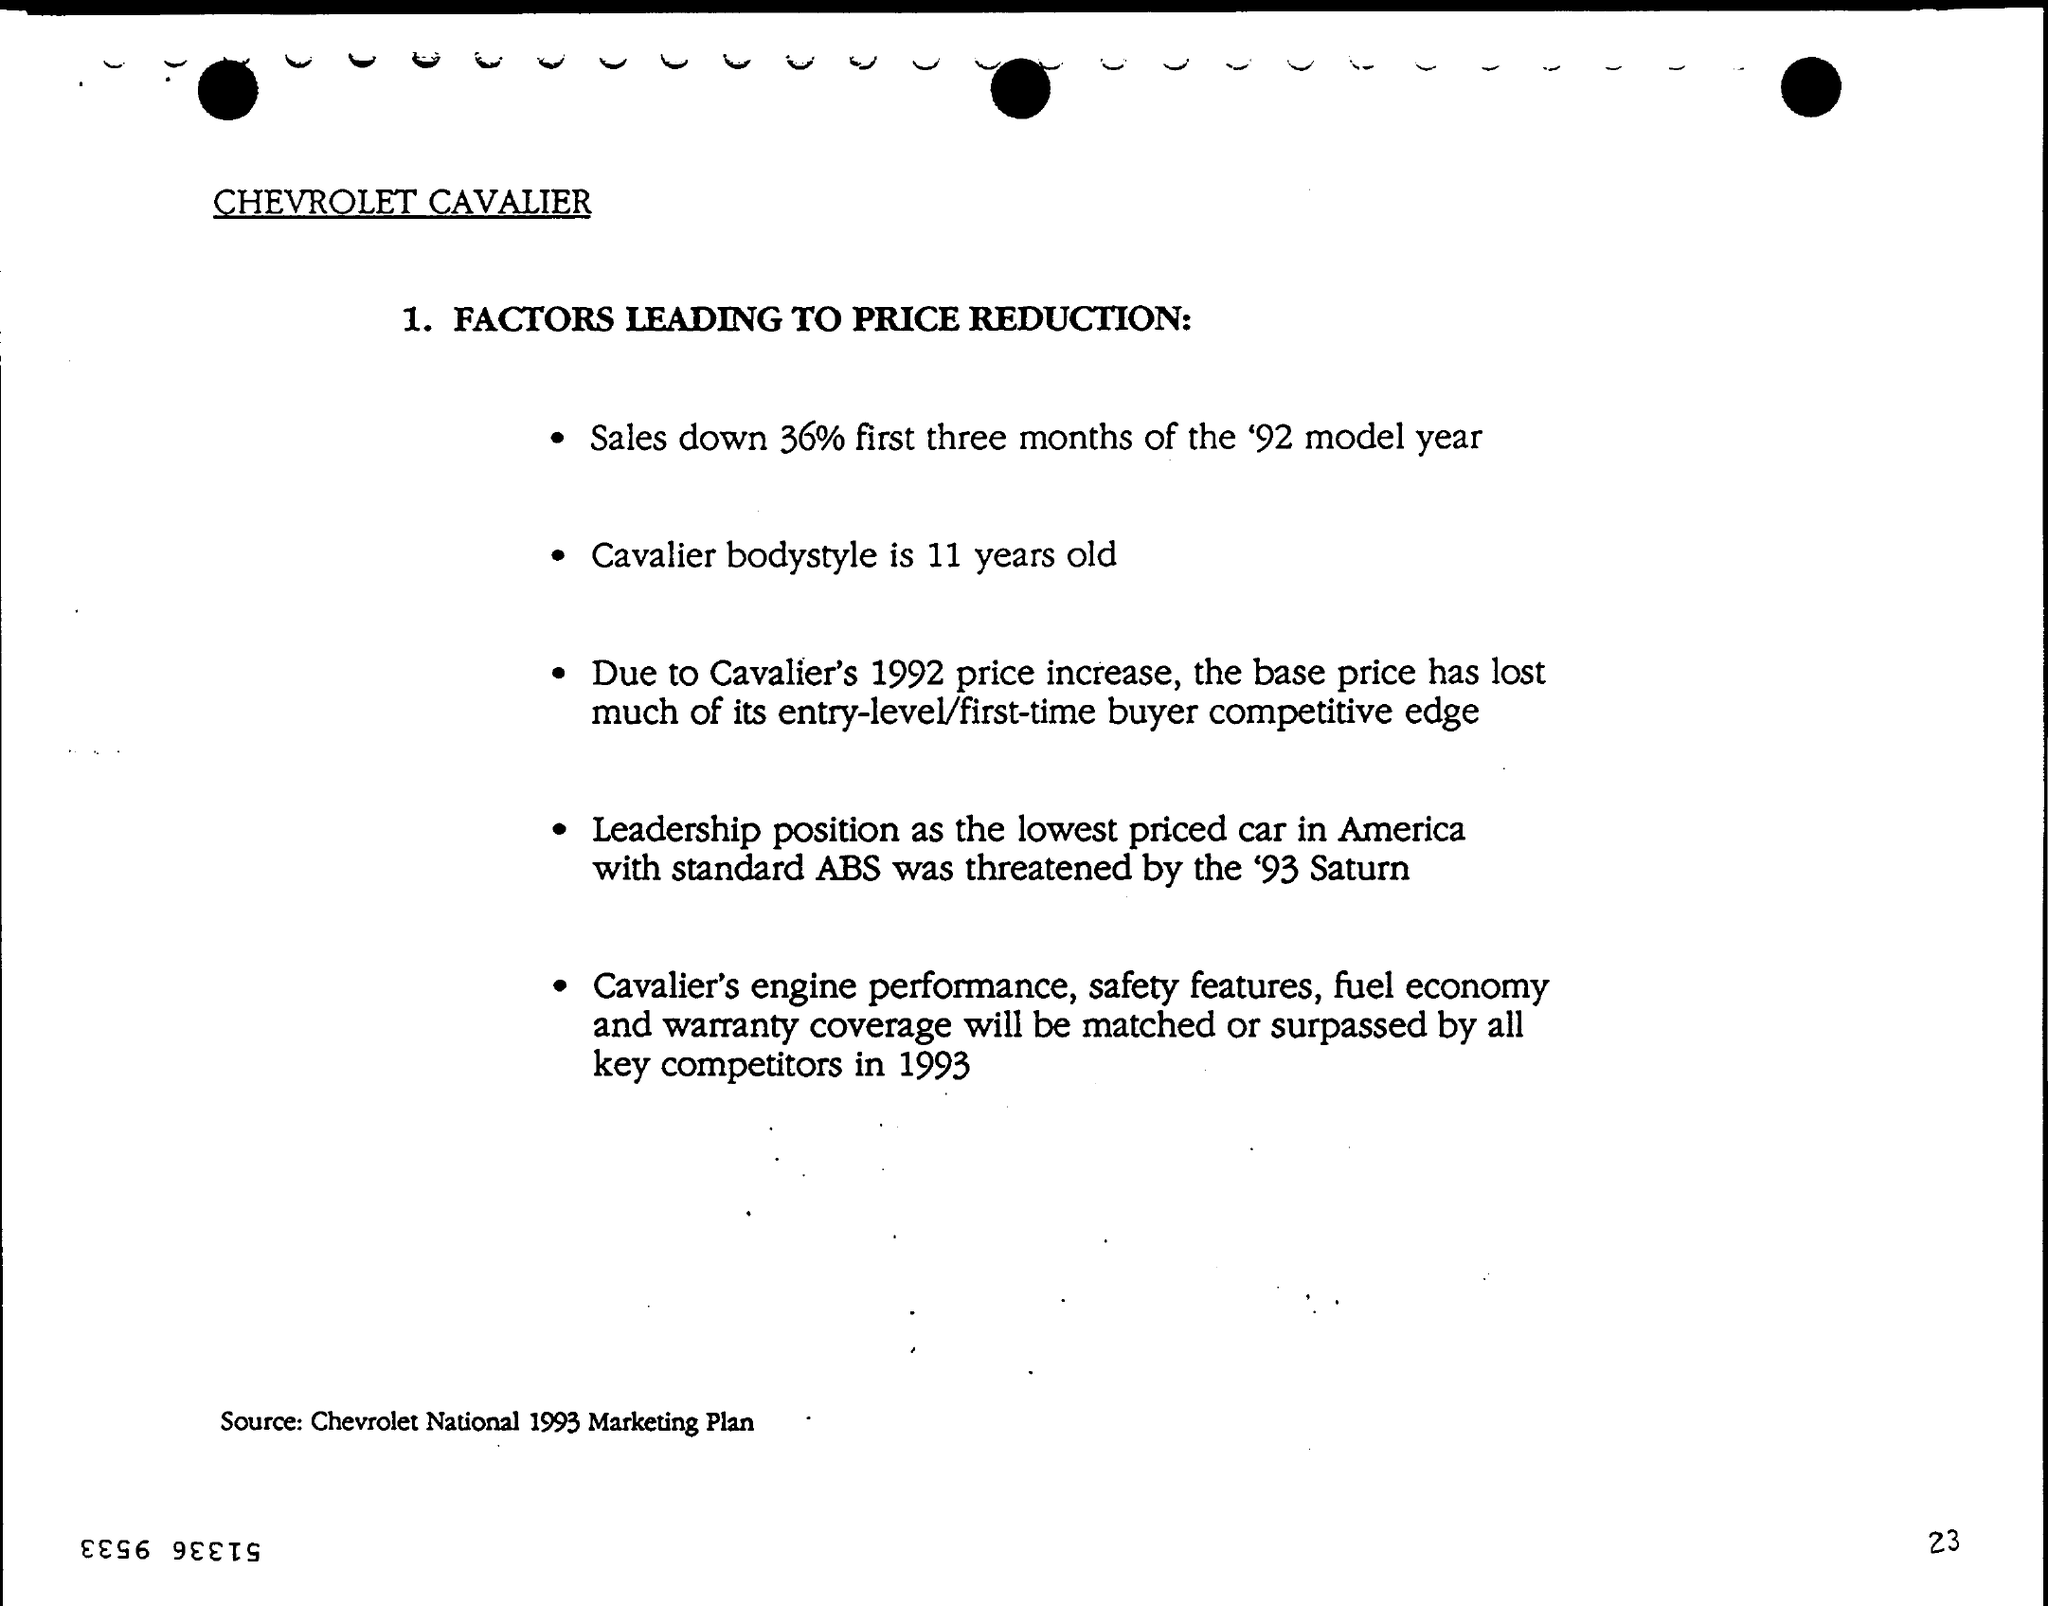Specify some key components in this picture. According to the source mentioned at the bottom of the page, the Chevrolet National 1993 Marketing Plan was a document that outlined the marketing strategies and goals of Chevrolet in 1993. Sales declined by 36% during the first three months. The Cavalier bodystyle is 11 years old. The Chevrolet Cavalier brand is mentioned. 